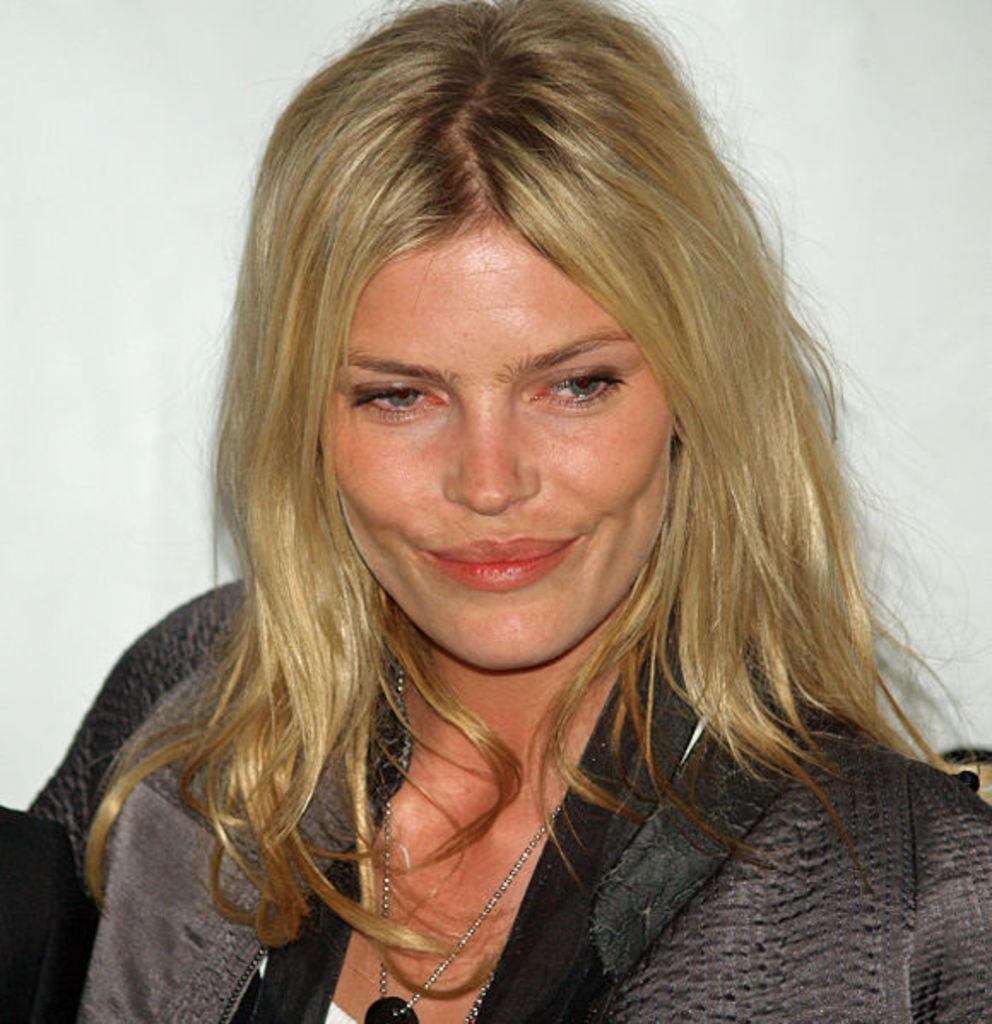Could you give a brief overview of what you see in this image? There is a lady wearing a chain. In the background there is a white wall. 